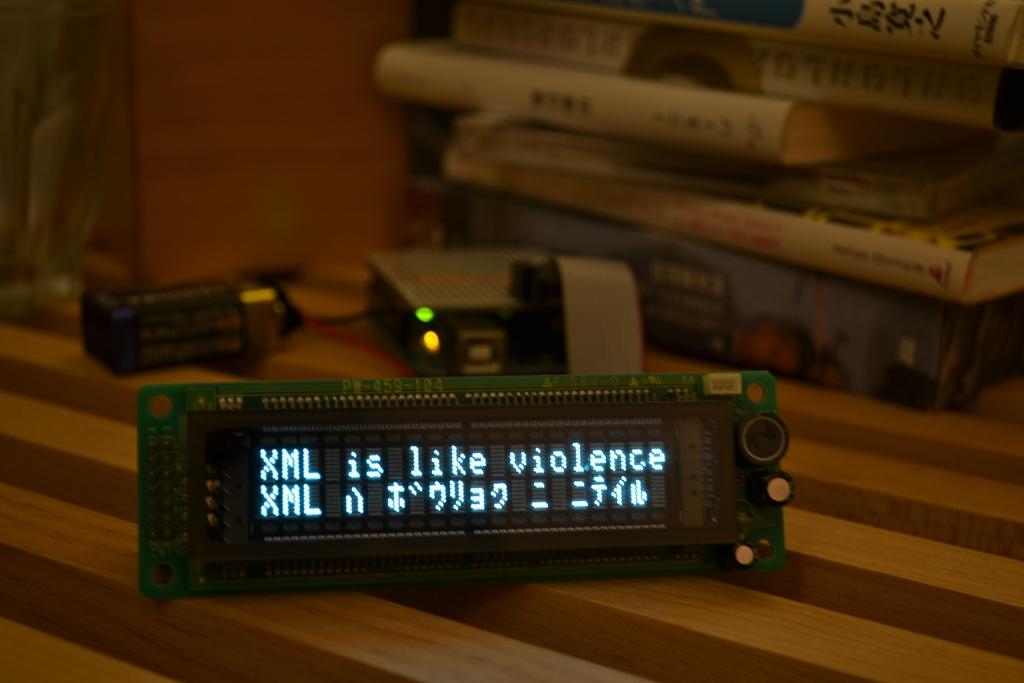<image>
Summarize the visual content of the image. a radio screen that says 'xml is like violence' on it 